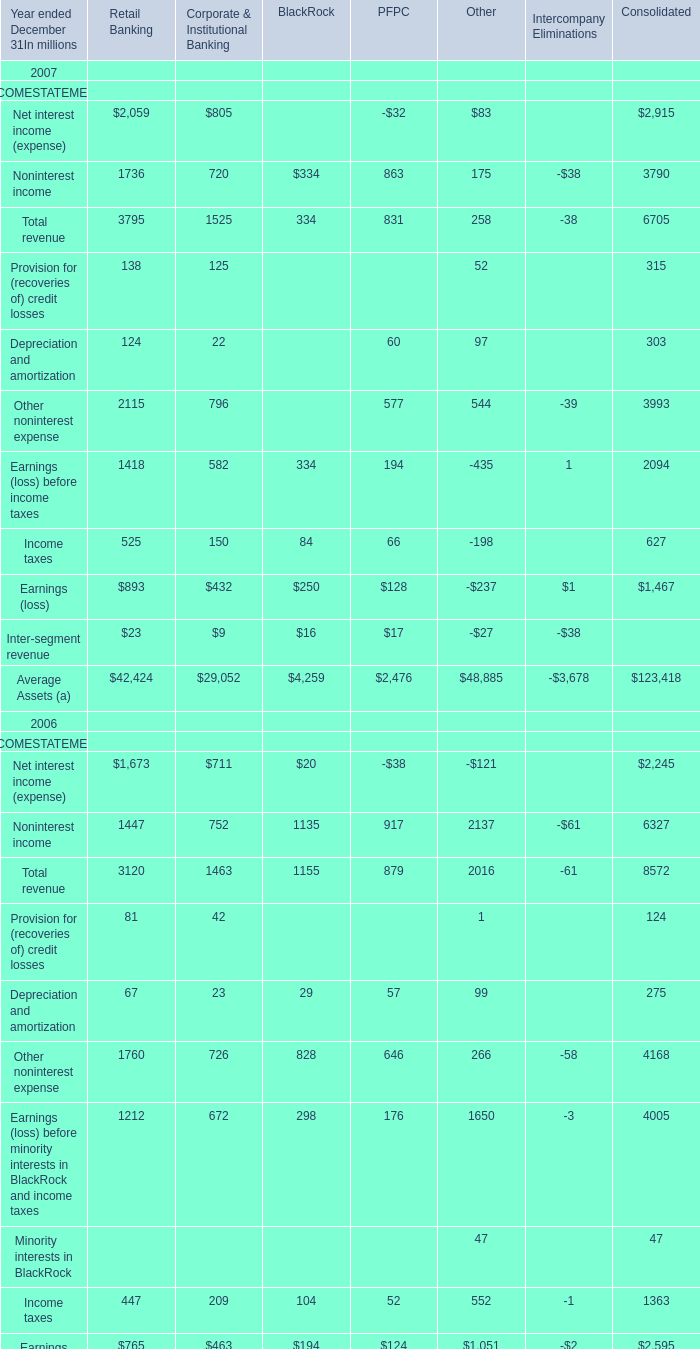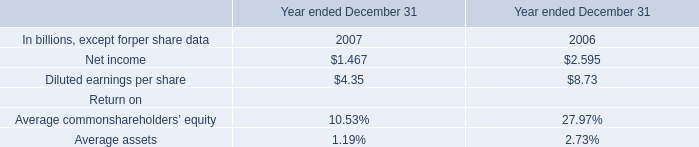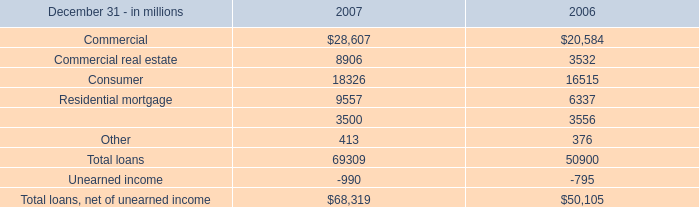for 2007 and 2006 in millions , what was average residential mortgage loan balance? 
Computations: ((9557 + 6337) / 2)
Answer: 7947.0. 